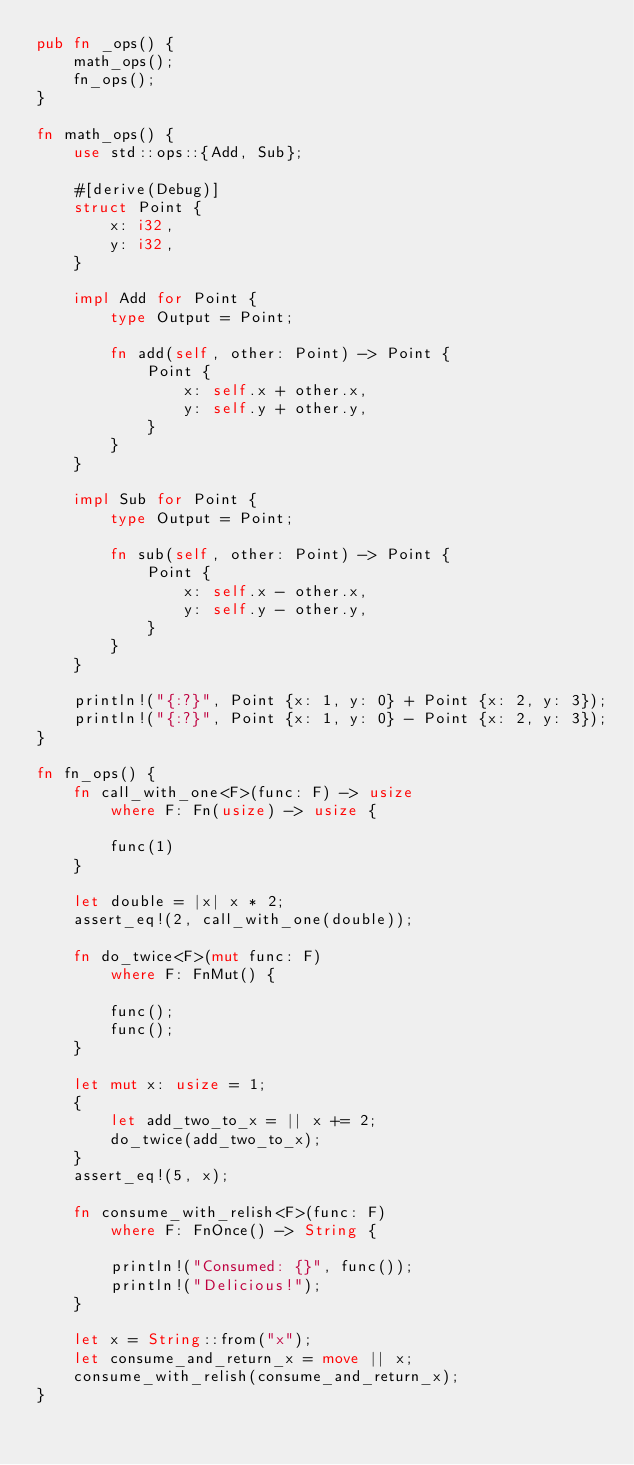Convert code to text. <code><loc_0><loc_0><loc_500><loc_500><_Rust_>pub fn _ops() {
    math_ops();
    fn_ops();
}

fn math_ops() {
    use std::ops::{Add, Sub};

    #[derive(Debug)]
    struct Point {
        x: i32,
        y: i32,
    }

    impl Add for Point {
        type Output = Point;

        fn add(self, other: Point) -> Point {
            Point {
                x: self.x + other.x,
                y: self.y + other.y,
            }
        }
    }

    impl Sub for Point {
        type Output = Point;

        fn sub(self, other: Point) -> Point {
            Point {
                x: self.x - other.x,
                y: self.y - other.y,
            }
        }
    }

    println!("{:?}", Point {x: 1, y: 0} + Point {x: 2, y: 3});
    println!("{:?}", Point {x: 1, y: 0} - Point {x: 2, y: 3});
}

fn fn_ops() {
    fn call_with_one<F>(func: F) -> usize
        where F: Fn(usize) -> usize {

        func(1)
    }

    let double = |x| x * 2;
    assert_eq!(2, call_with_one(double));

    fn do_twice<F>(mut func: F)
        where F: FnMut() {

        func();
        func();
    }

    let mut x: usize = 1;
    {
        let add_two_to_x = || x += 2;
        do_twice(add_two_to_x);
    }
    assert_eq!(5, x);

    fn consume_with_relish<F>(func: F)
        where F: FnOnce() -> String {

        println!("Consumed: {}", func());
        println!("Delicious!");
    }

    let x = String::from("x");
    let consume_and_return_x = move || x;
    consume_with_relish(consume_and_return_x);
}
</code> 